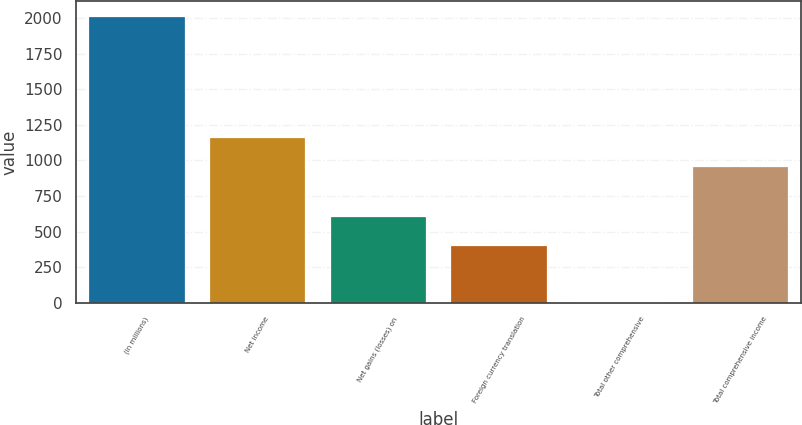<chart> <loc_0><loc_0><loc_500><loc_500><bar_chart><fcel>(In millions)<fcel>Net income<fcel>Net gains (losses) on<fcel>Foreign currency translation<fcel>Total other comprehensive<fcel>Total comprehensive income<nl><fcel>2017<fcel>1165.4<fcel>607.2<fcel>405.8<fcel>3<fcel>964<nl></chart> 